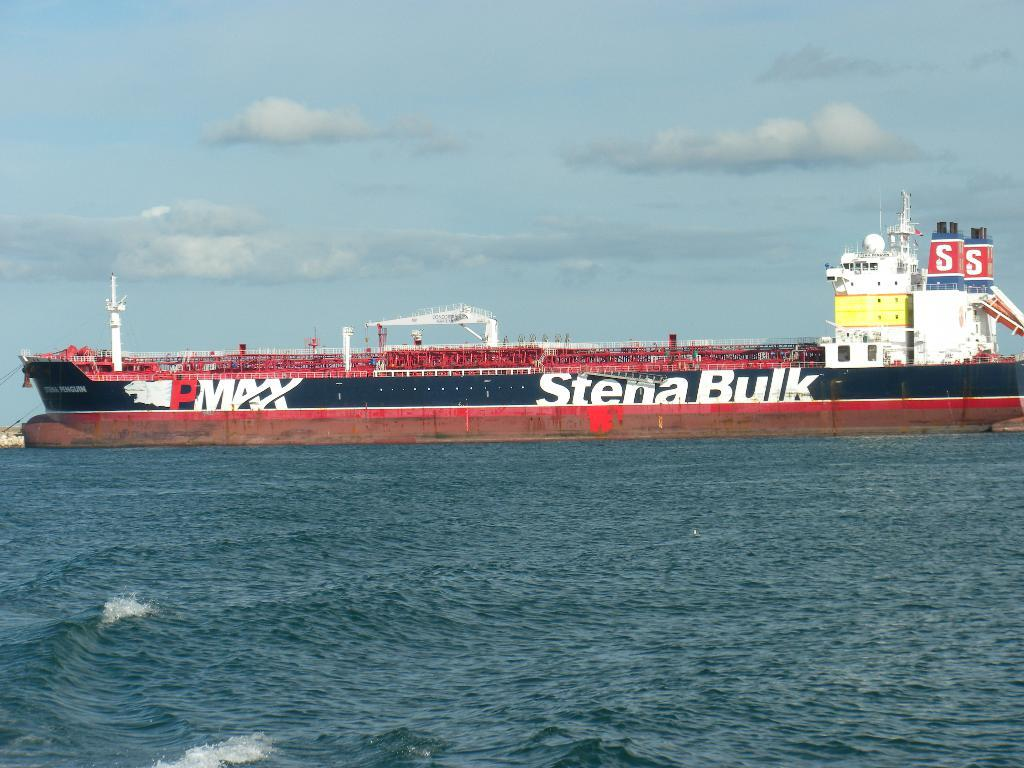What is the main subject of the image? There is a ship in the image. Where is the ship located? The ship is on the ocean. What else can be seen in the image besides the ship? The sky is visible in the image. How would you describe the sky in the image? The sky appears to be cloudy. What note is the ship playing in the image? There is no indication that the ship is playing a note or any musical instrument in the image. 